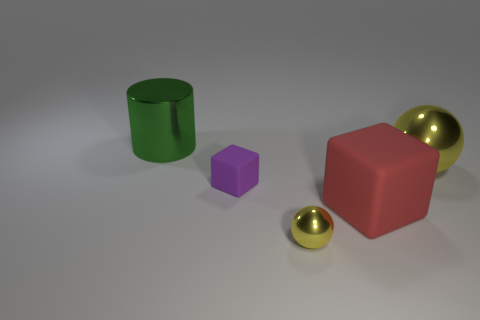Add 5 green metal things. How many objects exist? 10 Subtract all cubes. How many objects are left? 3 Subtract all yellow metallic objects. Subtract all gray spheres. How many objects are left? 3 Add 4 green metal cylinders. How many green metal cylinders are left? 5 Add 4 tiny green objects. How many tiny green objects exist? 4 Subtract 0 blue cylinders. How many objects are left? 5 